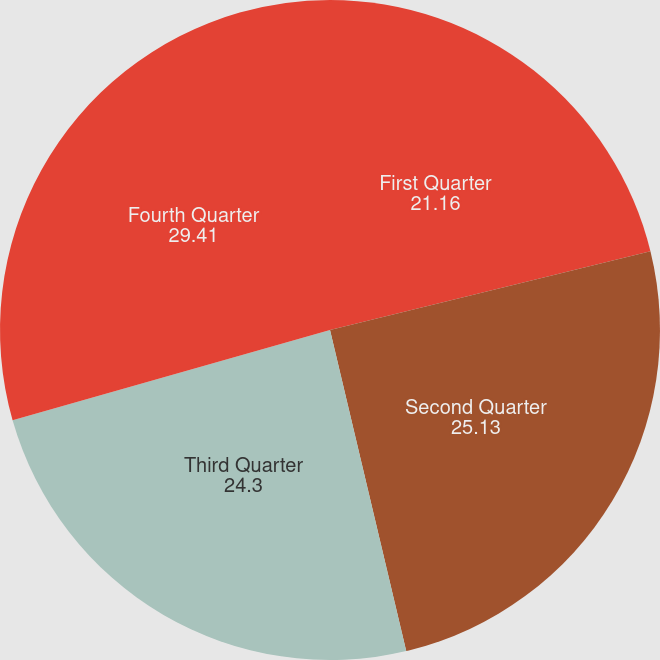<chart> <loc_0><loc_0><loc_500><loc_500><pie_chart><fcel>First Quarter<fcel>Second Quarter<fcel>Third Quarter<fcel>Fourth Quarter<nl><fcel>21.16%<fcel>25.13%<fcel>24.3%<fcel>29.41%<nl></chart> 